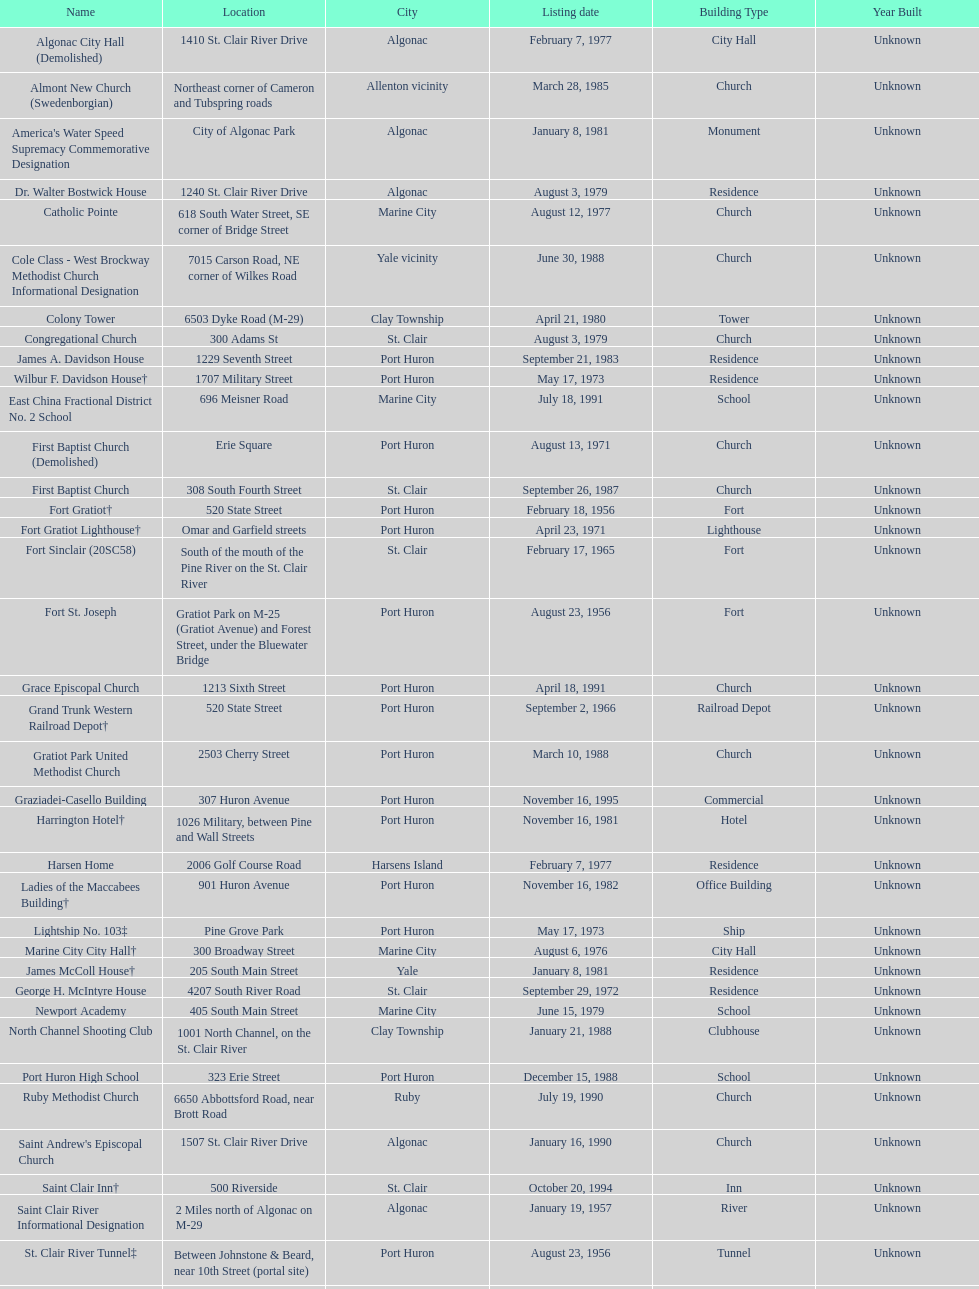Can you parse all the data within this table? {'header': ['Name', 'Location', 'City', 'Listing date', 'Building Type', 'Year Built'], 'rows': [['Algonac City Hall (Demolished)', '1410 St. Clair River Drive', 'Algonac', 'February 7, 1977', 'City Hall', 'Unknown'], ['Almont New Church (Swedenborgian)', 'Northeast corner of Cameron and Tubspring roads', 'Allenton vicinity', 'March 28, 1985', 'Church', 'Unknown'], ["America's Water Speed Supremacy Commemorative Designation", 'City of Algonac Park', 'Algonac', 'January 8, 1981', 'Monument', 'Unknown'], ['Dr. Walter Bostwick House', '1240 St. Clair River Drive', 'Algonac', 'August 3, 1979', 'Residence', 'Unknown'], ['Catholic Pointe', '618 South Water Street, SE corner of Bridge Street', 'Marine City', 'August 12, 1977', 'Church', 'Unknown'], ['Cole Class - West Brockway Methodist Church Informational Designation', '7015 Carson Road, NE corner of Wilkes Road', 'Yale vicinity', 'June 30, 1988', 'Church', 'Unknown'], ['Colony Tower', '6503 Dyke Road (M-29)', 'Clay Township', 'April 21, 1980', 'Tower', 'Unknown'], ['Congregational Church', '300 Adams St', 'St. Clair', 'August 3, 1979', 'Church', 'Unknown'], ['James A. Davidson House', '1229 Seventh Street', 'Port Huron', 'September 21, 1983', 'Residence', 'Unknown'], ['Wilbur F. Davidson House†', '1707 Military Street', 'Port Huron', 'May 17, 1973', 'Residence', 'Unknown'], ['East China Fractional District No. 2 School', '696 Meisner Road', 'Marine City', 'July 18, 1991', 'School', 'Unknown'], ['First Baptist Church (Demolished)', 'Erie Square', 'Port Huron', 'August 13, 1971', 'Church', 'Unknown'], ['First Baptist Church', '308 South Fourth Street', 'St. Clair', 'September 26, 1987', 'Church', 'Unknown'], ['Fort Gratiot†', '520 State Street', 'Port Huron', 'February 18, 1956', 'Fort', 'Unknown'], ['Fort Gratiot Lighthouse†', 'Omar and Garfield streets', 'Port Huron', 'April 23, 1971', 'Lighthouse', 'Unknown'], ['Fort Sinclair (20SC58)', 'South of the mouth of the Pine River on the St. Clair River', 'St. Clair', 'February 17, 1965', 'Fort', 'Unknown'], ['Fort St. Joseph', 'Gratiot Park on M-25 (Gratiot Avenue) and Forest Street, under the Bluewater Bridge', 'Port Huron', 'August 23, 1956', 'Fort', 'Unknown'], ['Grace Episcopal Church', '1213 Sixth Street', 'Port Huron', 'April 18, 1991', 'Church', 'Unknown'], ['Grand Trunk Western Railroad Depot†', '520 State Street', 'Port Huron', 'September 2, 1966', 'Railroad Depot', 'Unknown'], ['Gratiot Park United Methodist Church', '2503 Cherry Street', 'Port Huron', 'March 10, 1988', 'Church', 'Unknown'], ['Graziadei-Casello Building', '307 Huron Avenue', 'Port Huron', 'November 16, 1995', 'Commercial', 'Unknown'], ['Harrington Hotel†', '1026 Military, between Pine and Wall Streets', 'Port Huron', 'November 16, 1981', 'Hotel', 'Unknown'], ['Harsen Home', '2006 Golf Course Road', 'Harsens Island', 'February 7, 1977', 'Residence', 'Unknown'], ['Ladies of the Maccabees Building†', '901 Huron Avenue', 'Port Huron', 'November 16, 1982', 'Office Building', 'Unknown'], ['Lightship No. 103‡', 'Pine Grove Park', 'Port Huron', 'May 17, 1973', 'Ship', 'Unknown'], ['Marine City City Hall†', '300 Broadway Street', 'Marine City', 'August 6, 1976', 'City Hall', 'Unknown'], ['James McColl House†', '205 South Main Street', 'Yale', 'January 8, 1981', 'Residence', 'Unknown'], ['George H. McIntyre House', '4207 South River Road', 'St. Clair', 'September 29, 1972', 'Residence', 'Unknown'], ['Newport Academy', '405 South Main Street', 'Marine City', 'June 15, 1979', 'School', 'Unknown'], ['North Channel Shooting Club', '1001 North Channel, on the St. Clair River', 'Clay Township', 'January 21, 1988', 'Clubhouse', 'Unknown'], ['Port Huron High School', '323 Erie Street', 'Port Huron', 'December 15, 1988', 'School', 'Unknown'], ['Ruby Methodist Church', '6650 Abbottsford Road, near Brott Road', 'Ruby', 'July 19, 1990', 'Church', 'Unknown'], ["Saint Andrew's Episcopal Church", '1507 St. Clair River Drive', 'Algonac', 'January 16, 1990', 'Church', 'Unknown'], ['Saint Clair Inn†', '500 Riverside', 'St. Clair', 'October 20, 1994', 'Inn', 'Unknown'], ['Saint Clair River Informational Designation', '2 Miles north of Algonac on M-29', 'Algonac', 'January 19, 1957', 'River', 'Unknown'], ['St. Clair River Tunnel‡', 'Between Johnstone & Beard, near 10th Street (portal site)', 'Port Huron', 'August 23, 1956', 'Tunnel', 'Unknown'], ['Saint Johannes Evangelische Kirche', '710 Pine Street, at Seventh Street', 'Port Huron', 'March 19, 1980', 'Church', 'Unknown'], ["Saint Mary's Catholic Church and Rectory", '415 North Sixth Street, between Vine and Orchard streets', 'St. Clair', 'September 25, 1985', 'Church and Rectory', 'Unknown'], ['Jefferson Sheldon House', '807 Prospect Place', 'Port Huron', 'April 19, 1990', 'Residence', 'Unknown'], ['Trinity Evangelical Lutheran Church', '1517 Tenth Street', 'Port Huron', 'August 29, 1996', 'Church', 'Unknown'], ['Wales Township Hall', '1372 Wales Center', 'Wales Township', 'July 18, 1996', 'Township Hall', 'Unknown'], ['Ward-Holland House†', '433 North Main Street', 'Marine City', 'May 5, 1964', 'Residence', 'Unknown'], ['E. C. Williams House', '2511 Tenth Avenue, between Hancock and Church streets', 'Port Huron', 'November 18, 1993', 'Residence', 'Unknown'], ['C. H. Wills & Company', 'Chrysler Plant, 840 Huron Avenue', 'Marysville', 'June 23, 1983', 'Factory', 'Unknown'], ["Woman's Benefit Association Building", '1338 Military Street', 'Port Huron', 'December 15, 1988', 'Office Building', 'Unknown']]} Fort gratiot lighthouse and fort st. joseph are located in what city? Port Huron. 